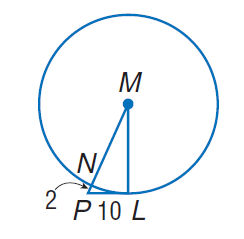Question: Find the perimeter of the polygon for the given information.
Choices:
A. 2
B. 10
C. 30
D. 60
Answer with the letter. Answer: D 